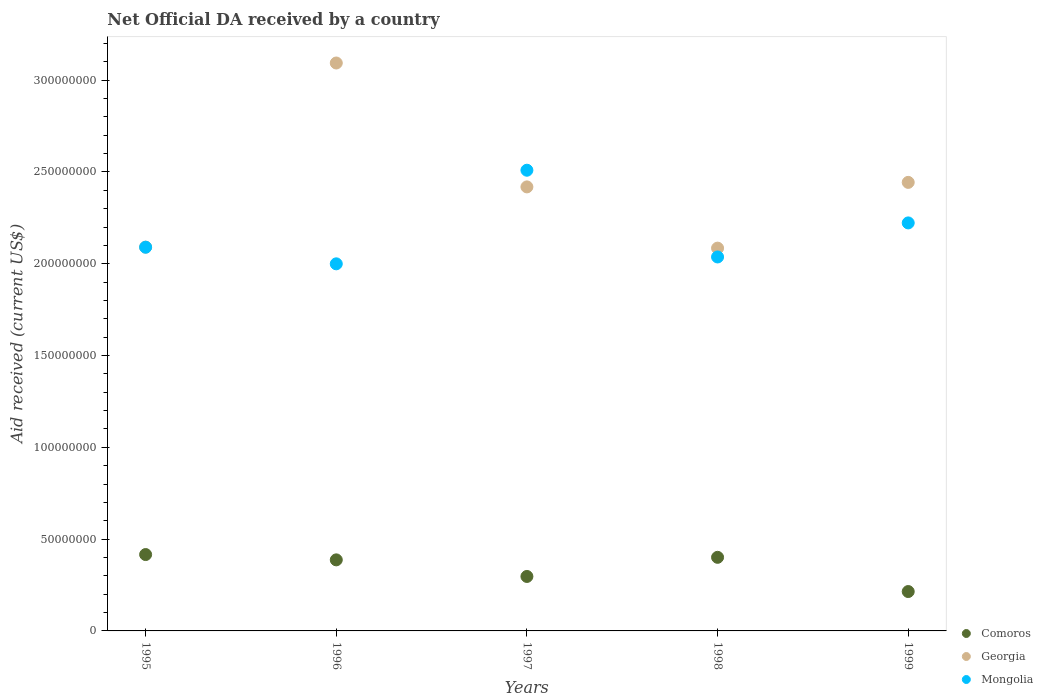How many different coloured dotlines are there?
Provide a short and direct response. 3. What is the net official development assistance aid received in Mongolia in 1998?
Your answer should be very brief. 2.04e+08. Across all years, what is the maximum net official development assistance aid received in Comoros?
Keep it short and to the point. 4.16e+07. Across all years, what is the minimum net official development assistance aid received in Mongolia?
Your answer should be very brief. 2.00e+08. In which year was the net official development assistance aid received in Comoros maximum?
Keep it short and to the point. 1995. In which year was the net official development assistance aid received in Georgia minimum?
Make the answer very short. 1998. What is the total net official development assistance aid received in Comoros in the graph?
Give a very brief answer. 1.72e+08. What is the difference between the net official development assistance aid received in Mongolia in 1996 and that in 1997?
Ensure brevity in your answer.  -5.10e+07. What is the difference between the net official development assistance aid received in Georgia in 1998 and the net official development assistance aid received in Mongolia in 1997?
Make the answer very short. -4.24e+07. What is the average net official development assistance aid received in Georgia per year?
Ensure brevity in your answer.  2.43e+08. In the year 1997, what is the difference between the net official development assistance aid received in Georgia and net official development assistance aid received in Comoros?
Your answer should be very brief. 2.12e+08. In how many years, is the net official development assistance aid received in Mongolia greater than 80000000 US$?
Your answer should be compact. 5. What is the ratio of the net official development assistance aid received in Georgia in 1996 to that in 1998?
Offer a terse response. 1.48. Is the net official development assistance aid received in Comoros in 1996 less than that in 1998?
Your answer should be very brief. Yes. What is the difference between the highest and the second highest net official development assistance aid received in Mongolia?
Ensure brevity in your answer.  2.87e+07. What is the difference between the highest and the lowest net official development assistance aid received in Georgia?
Offer a very short reply. 1.01e+08. In how many years, is the net official development assistance aid received in Georgia greater than the average net official development assistance aid received in Georgia taken over all years?
Your answer should be compact. 2. Is the sum of the net official development assistance aid received in Comoros in 1997 and 1999 greater than the maximum net official development assistance aid received in Georgia across all years?
Make the answer very short. No. Is it the case that in every year, the sum of the net official development assistance aid received in Mongolia and net official development assistance aid received in Georgia  is greater than the net official development assistance aid received in Comoros?
Your answer should be very brief. Yes. Is the net official development assistance aid received in Georgia strictly greater than the net official development assistance aid received in Mongolia over the years?
Offer a very short reply. No. Is the net official development assistance aid received in Georgia strictly less than the net official development assistance aid received in Mongolia over the years?
Provide a short and direct response. No. What is the difference between two consecutive major ticks on the Y-axis?
Offer a very short reply. 5.00e+07. Does the graph contain any zero values?
Keep it short and to the point. No. Does the graph contain grids?
Ensure brevity in your answer.  No. How many legend labels are there?
Make the answer very short. 3. What is the title of the graph?
Your response must be concise. Net Official DA received by a country. Does "San Marino" appear as one of the legend labels in the graph?
Ensure brevity in your answer.  No. What is the label or title of the Y-axis?
Offer a very short reply. Aid received (current US$). What is the Aid received (current US$) in Comoros in 1995?
Your answer should be very brief. 4.16e+07. What is the Aid received (current US$) in Georgia in 1995?
Make the answer very short. 2.09e+08. What is the Aid received (current US$) of Mongolia in 1995?
Provide a succinct answer. 2.09e+08. What is the Aid received (current US$) in Comoros in 1996?
Your answer should be very brief. 3.87e+07. What is the Aid received (current US$) in Georgia in 1996?
Ensure brevity in your answer.  3.09e+08. What is the Aid received (current US$) of Mongolia in 1996?
Give a very brief answer. 2.00e+08. What is the Aid received (current US$) of Comoros in 1997?
Provide a short and direct response. 2.97e+07. What is the Aid received (current US$) in Georgia in 1997?
Make the answer very short. 2.42e+08. What is the Aid received (current US$) of Mongolia in 1997?
Ensure brevity in your answer.  2.51e+08. What is the Aid received (current US$) in Comoros in 1998?
Offer a very short reply. 4.01e+07. What is the Aid received (current US$) of Georgia in 1998?
Make the answer very short. 2.09e+08. What is the Aid received (current US$) in Mongolia in 1998?
Provide a short and direct response. 2.04e+08. What is the Aid received (current US$) in Comoros in 1999?
Offer a very short reply. 2.14e+07. What is the Aid received (current US$) of Georgia in 1999?
Your answer should be compact. 2.44e+08. What is the Aid received (current US$) in Mongolia in 1999?
Offer a very short reply. 2.22e+08. Across all years, what is the maximum Aid received (current US$) of Comoros?
Keep it short and to the point. 4.16e+07. Across all years, what is the maximum Aid received (current US$) in Georgia?
Keep it short and to the point. 3.09e+08. Across all years, what is the maximum Aid received (current US$) of Mongolia?
Offer a terse response. 2.51e+08. Across all years, what is the minimum Aid received (current US$) in Comoros?
Your answer should be very brief. 2.14e+07. Across all years, what is the minimum Aid received (current US$) in Georgia?
Keep it short and to the point. 2.09e+08. Across all years, what is the minimum Aid received (current US$) of Mongolia?
Give a very brief answer. 2.00e+08. What is the total Aid received (current US$) in Comoros in the graph?
Your answer should be compact. 1.72e+08. What is the total Aid received (current US$) of Georgia in the graph?
Your response must be concise. 1.21e+09. What is the total Aid received (current US$) in Mongolia in the graph?
Offer a terse response. 1.09e+09. What is the difference between the Aid received (current US$) in Comoros in 1995 and that in 1996?
Give a very brief answer. 2.89e+06. What is the difference between the Aid received (current US$) of Georgia in 1995 and that in 1996?
Offer a very short reply. -1.00e+08. What is the difference between the Aid received (current US$) in Mongolia in 1995 and that in 1996?
Keep it short and to the point. 9.05e+06. What is the difference between the Aid received (current US$) of Comoros in 1995 and that in 1997?
Give a very brief answer. 1.19e+07. What is the difference between the Aid received (current US$) of Georgia in 1995 and that in 1997?
Your answer should be compact. -3.28e+07. What is the difference between the Aid received (current US$) in Mongolia in 1995 and that in 1997?
Offer a terse response. -4.19e+07. What is the difference between the Aid received (current US$) in Comoros in 1995 and that in 1998?
Offer a terse response. 1.51e+06. What is the difference between the Aid received (current US$) in Georgia in 1995 and that in 1998?
Your answer should be very brief. 5.40e+05. What is the difference between the Aid received (current US$) in Mongolia in 1995 and that in 1998?
Give a very brief answer. 5.31e+06. What is the difference between the Aid received (current US$) in Comoros in 1995 and that in 1999?
Ensure brevity in your answer.  2.02e+07. What is the difference between the Aid received (current US$) in Georgia in 1995 and that in 1999?
Ensure brevity in your answer.  -3.53e+07. What is the difference between the Aid received (current US$) of Mongolia in 1995 and that in 1999?
Give a very brief answer. -1.32e+07. What is the difference between the Aid received (current US$) in Comoros in 1996 and that in 1997?
Provide a succinct answer. 9.04e+06. What is the difference between the Aid received (current US$) of Georgia in 1996 and that in 1997?
Ensure brevity in your answer.  6.75e+07. What is the difference between the Aid received (current US$) of Mongolia in 1996 and that in 1997?
Give a very brief answer. -5.10e+07. What is the difference between the Aid received (current US$) in Comoros in 1996 and that in 1998?
Keep it short and to the point. -1.38e+06. What is the difference between the Aid received (current US$) of Georgia in 1996 and that in 1998?
Provide a short and direct response. 1.01e+08. What is the difference between the Aid received (current US$) of Mongolia in 1996 and that in 1998?
Your answer should be compact. -3.74e+06. What is the difference between the Aid received (current US$) of Comoros in 1996 and that in 1999?
Provide a short and direct response. 1.73e+07. What is the difference between the Aid received (current US$) of Georgia in 1996 and that in 1999?
Your answer should be compact. 6.50e+07. What is the difference between the Aid received (current US$) in Mongolia in 1996 and that in 1999?
Ensure brevity in your answer.  -2.23e+07. What is the difference between the Aid received (current US$) of Comoros in 1997 and that in 1998?
Offer a terse response. -1.04e+07. What is the difference between the Aid received (current US$) in Georgia in 1997 and that in 1998?
Offer a terse response. 3.34e+07. What is the difference between the Aid received (current US$) of Mongolia in 1997 and that in 1998?
Your answer should be compact. 4.72e+07. What is the difference between the Aid received (current US$) in Comoros in 1997 and that in 1999?
Provide a short and direct response. 8.22e+06. What is the difference between the Aid received (current US$) in Georgia in 1997 and that in 1999?
Provide a short and direct response. -2.46e+06. What is the difference between the Aid received (current US$) of Mongolia in 1997 and that in 1999?
Ensure brevity in your answer.  2.87e+07. What is the difference between the Aid received (current US$) of Comoros in 1998 and that in 1999?
Give a very brief answer. 1.86e+07. What is the difference between the Aid received (current US$) of Georgia in 1998 and that in 1999?
Keep it short and to the point. -3.58e+07. What is the difference between the Aid received (current US$) of Mongolia in 1998 and that in 1999?
Provide a succinct answer. -1.86e+07. What is the difference between the Aid received (current US$) of Comoros in 1995 and the Aid received (current US$) of Georgia in 1996?
Provide a succinct answer. -2.68e+08. What is the difference between the Aid received (current US$) in Comoros in 1995 and the Aid received (current US$) in Mongolia in 1996?
Keep it short and to the point. -1.58e+08. What is the difference between the Aid received (current US$) of Georgia in 1995 and the Aid received (current US$) of Mongolia in 1996?
Offer a terse response. 9.09e+06. What is the difference between the Aid received (current US$) of Comoros in 1995 and the Aid received (current US$) of Georgia in 1997?
Your answer should be compact. -2.00e+08. What is the difference between the Aid received (current US$) in Comoros in 1995 and the Aid received (current US$) in Mongolia in 1997?
Your answer should be very brief. -2.09e+08. What is the difference between the Aid received (current US$) in Georgia in 1995 and the Aid received (current US$) in Mongolia in 1997?
Your answer should be very brief. -4.19e+07. What is the difference between the Aid received (current US$) of Comoros in 1995 and the Aid received (current US$) of Georgia in 1998?
Offer a terse response. -1.67e+08. What is the difference between the Aid received (current US$) of Comoros in 1995 and the Aid received (current US$) of Mongolia in 1998?
Provide a short and direct response. -1.62e+08. What is the difference between the Aid received (current US$) in Georgia in 1995 and the Aid received (current US$) in Mongolia in 1998?
Your answer should be compact. 5.35e+06. What is the difference between the Aid received (current US$) in Comoros in 1995 and the Aid received (current US$) in Georgia in 1999?
Ensure brevity in your answer.  -2.03e+08. What is the difference between the Aid received (current US$) of Comoros in 1995 and the Aid received (current US$) of Mongolia in 1999?
Your response must be concise. -1.81e+08. What is the difference between the Aid received (current US$) of Georgia in 1995 and the Aid received (current US$) of Mongolia in 1999?
Your answer should be compact. -1.32e+07. What is the difference between the Aid received (current US$) in Comoros in 1996 and the Aid received (current US$) in Georgia in 1997?
Provide a succinct answer. -2.03e+08. What is the difference between the Aid received (current US$) in Comoros in 1996 and the Aid received (current US$) in Mongolia in 1997?
Provide a succinct answer. -2.12e+08. What is the difference between the Aid received (current US$) of Georgia in 1996 and the Aid received (current US$) of Mongolia in 1997?
Your answer should be compact. 5.84e+07. What is the difference between the Aid received (current US$) in Comoros in 1996 and the Aid received (current US$) in Georgia in 1998?
Give a very brief answer. -1.70e+08. What is the difference between the Aid received (current US$) in Comoros in 1996 and the Aid received (current US$) in Mongolia in 1998?
Keep it short and to the point. -1.65e+08. What is the difference between the Aid received (current US$) in Georgia in 1996 and the Aid received (current US$) in Mongolia in 1998?
Give a very brief answer. 1.06e+08. What is the difference between the Aid received (current US$) of Comoros in 1996 and the Aid received (current US$) of Georgia in 1999?
Your answer should be compact. -2.06e+08. What is the difference between the Aid received (current US$) of Comoros in 1996 and the Aid received (current US$) of Mongolia in 1999?
Offer a very short reply. -1.84e+08. What is the difference between the Aid received (current US$) in Georgia in 1996 and the Aid received (current US$) in Mongolia in 1999?
Your answer should be very brief. 8.71e+07. What is the difference between the Aid received (current US$) of Comoros in 1997 and the Aid received (current US$) of Georgia in 1998?
Offer a very short reply. -1.79e+08. What is the difference between the Aid received (current US$) of Comoros in 1997 and the Aid received (current US$) of Mongolia in 1998?
Offer a very short reply. -1.74e+08. What is the difference between the Aid received (current US$) in Georgia in 1997 and the Aid received (current US$) in Mongolia in 1998?
Keep it short and to the point. 3.82e+07. What is the difference between the Aid received (current US$) of Comoros in 1997 and the Aid received (current US$) of Georgia in 1999?
Your answer should be compact. -2.15e+08. What is the difference between the Aid received (current US$) of Comoros in 1997 and the Aid received (current US$) of Mongolia in 1999?
Your response must be concise. -1.93e+08. What is the difference between the Aid received (current US$) in Georgia in 1997 and the Aid received (current US$) in Mongolia in 1999?
Your answer should be very brief. 1.96e+07. What is the difference between the Aid received (current US$) of Comoros in 1998 and the Aid received (current US$) of Georgia in 1999?
Offer a terse response. -2.04e+08. What is the difference between the Aid received (current US$) in Comoros in 1998 and the Aid received (current US$) in Mongolia in 1999?
Your answer should be compact. -1.82e+08. What is the difference between the Aid received (current US$) in Georgia in 1998 and the Aid received (current US$) in Mongolia in 1999?
Your answer should be very brief. -1.37e+07. What is the average Aid received (current US$) in Comoros per year?
Make the answer very short. 3.43e+07. What is the average Aid received (current US$) of Georgia per year?
Provide a succinct answer. 2.43e+08. What is the average Aid received (current US$) in Mongolia per year?
Offer a very short reply. 2.17e+08. In the year 1995, what is the difference between the Aid received (current US$) of Comoros and Aid received (current US$) of Georgia?
Make the answer very short. -1.67e+08. In the year 1995, what is the difference between the Aid received (current US$) in Comoros and Aid received (current US$) in Mongolia?
Your answer should be very brief. -1.67e+08. In the year 1996, what is the difference between the Aid received (current US$) of Comoros and Aid received (current US$) of Georgia?
Keep it short and to the point. -2.71e+08. In the year 1996, what is the difference between the Aid received (current US$) of Comoros and Aid received (current US$) of Mongolia?
Provide a short and direct response. -1.61e+08. In the year 1996, what is the difference between the Aid received (current US$) in Georgia and Aid received (current US$) in Mongolia?
Your answer should be very brief. 1.09e+08. In the year 1997, what is the difference between the Aid received (current US$) of Comoros and Aid received (current US$) of Georgia?
Your response must be concise. -2.12e+08. In the year 1997, what is the difference between the Aid received (current US$) of Comoros and Aid received (current US$) of Mongolia?
Keep it short and to the point. -2.21e+08. In the year 1997, what is the difference between the Aid received (current US$) of Georgia and Aid received (current US$) of Mongolia?
Provide a succinct answer. -9.08e+06. In the year 1998, what is the difference between the Aid received (current US$) of Comoros and Aid received (current US$) of Georgia?
Offer a very short reply. -1.68e+08. In the year 1998, what is the difference between the Aid received (current US$) of Comoros and Aid received (current US$) of Mongolia?
Your answer should be very brief. -1.64e+08. In the year 1998, what is the difference between the Aid received (current US$) of Georgia and Aid received (current US$) of Mongolia?
Give a very brief answer. 4.81e+06. In the year 1999, what is the difference between the Aid received (current US$) in Comoros and Aid received (current US$) in Georgia?
Keep it short and to the point. -2.23e+08. In the year 1999, what is the difference between the Aid received (current US$) in Comoros and Aid received (current US$) in Mongolia?
Offer a terse response. -2.01e+08. In the year 1999, what is the difference between the Aid received (current US$) in Georgia and Aid received (current US$) in Mongolia?
Offer a very short reply. 2.21e+07. What is the ratio of the Aid received (current US$) of Comoros in 1995 to that in 1996?
Offer a very short reply. 1.07. What is the ratio of the Aid received (current US$) of Georgia in 1995 to that in 1996?
Offer a very short reply. 0.68. What is the ratio of the Aid received (current US$) in Mongolia in 1995 to that in 1996?
Provide a short and direct response. 1.05. What is the ratio of the Aid received (current US$) in Comoros in 1995 to that in 1997?
Provide a succinct answer. 1.4. What is the ratio of the Aid received (current US$) in Georgia in 1995 to that in 1997?
Your answer should be compact. 0.86. What is the ratio of the Aid received (current US$) in Mongolia in 1995 to that in 1997?
Make the answer very short. 0.83. What is the ratio of the Aid received (current US$) in Comoros in 1995 to that in 1998?
Keep it short and to the point. 1.04. What is the ratio of the Aid received (current US$) of Georgia in 1995 to that in 1998?
Provide a succinct answer. 1. What is the ratio of the Aid received (current US$) of Mongolia in 1995 to that in 1998?
Keep it short and to the point. 1.03. What is the ratio of the Aid received (current US$) in Comoros in 1995 to that in 1999?
Provide a short and direct response. 1.94. What is the ratio of the Aid received (current US$) of Georgia in 1995 to that in 1999?
Provide a succinct answer. 0.86. What is the ratio of the Aid received (current US$) in Mongolia in 1995 to that in 1999?
Ensure brevity in your answer.  0.94. What is the ratio of the Aid received (current US$) in Comoros in 1996 to that in 1997?
Make the answer very short. 1.3. What is the ratio of the Aid received (current US$) in Georgia in 1996 to that in 1997?
Provide a short and direct response. 1.28. What is the ratio of the Aid received (current US$) of Mongolia in 1996 to that in 1997?
Your answer should be very brief. 0.8. What is the ratio of the Aid received (current US$) of Comoros in 1996 to that in 1998?
Offer a terse response. 0.97. What is the ratio of the Aid received (current US$) of Georgia in 1996 to that in 1998?
Make the answer very short. 1.48. What is the ratio of the Aid received (current US$) of Mongolia in 1996 to that in 1998?
Make the answer very short. 0.98. What is the ratio of the Aid received (current US$) of Comoros in 1996 to that in 1999?
Provide a short and direct response. 1.8. What is the ratio of the Aid received (current US$) in Georgia in 1996 to that in 1999?
Offer a very short reply. 1.27. What is the ratio of the Aid received (current US$) in Mongolia in 1996 to that in 1999?
Your answer should be compact. 0.9. What is the ratio of the Aid received (current US$) of Comoros in 1997 to that in 1998?
Keep it short and to the point. 0.74. What is the ratio of the Aid received (current US$) of Georgia in 1997 to that in 1998?
Provide a short and direct response. 1.16. What is the ratio of the Aid received (current US$) of Mongolia in 1997 to that in 1998?
Provide a succinct answer. 1.23. What is the ratio of the Aid received (current US$) of Comoros in 1997 to that in 1999?
Make the answer very short. 1.38. What is the ratio of the Aid received (current US$) of Georgia in 1997 to that in 1999?
Your response must be concise. 0.99. What is the ratio of the Aid received (current US$) of Mongolia in 1997 to that in 1999?
Provide a short and direct response. 1.13. What is the ratio of the Aid received (current US$) of Comoros in 1998 to that in 1999?
Your answer should be very brief. 1.87. What is the ratio of the Aid received (current US$) of Georgia in 1998 to that in 1999?
Make the answer very short. 0.85. What is the ratio of the Aid received (current US$) of Mongolia in 1998 to that in 1999?
Give a very brief answer. 0.92. What is the difference between the highest and the second highest Aid received (current US$) of Comoros?
Keep it short and to the point. 1.51e+06. What is the difference between the highest and the second highest Aid received (current US$) in Georgia?
Make the answer very short. 6.50e+07. What is the difference between the highest and the second highest Aid received (current US$) in Mongolia?
Offer a very short reply. 2.87e+07. What is the difference between the highest and the lowest Aid received (current US$) in Comoros?
Your answer should be very brief. 2.02e+07. What is the difference between the highest and the lowest Aid received (current US$) in Georgia?
Offer a very short reply. 1.01e+08. What is the difference between the highest and the lowest Aid received (current US$) of Mongolia?
Provide a short and direct response. 5.10e+07. 